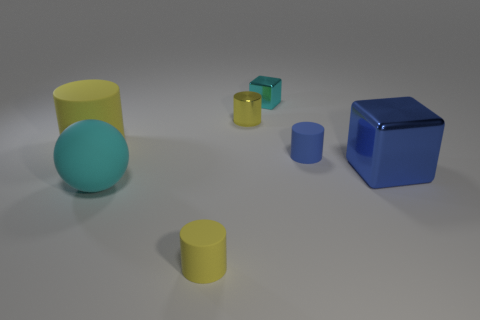The cyan object behind the yellow cylinder that is on the left side of the yellow rubber object in front of the big blue block is made of what material?
Your answer should be compact. Metal. What is the material of the small cube that is the same color as the ball?
Your answer should be compact. Metal. How many tiny blue objects are the same material as the big cylinder?
Provide a short and direct response. 1. Do the object that is on the left side of the matte sphere and the small cyan metallic cube have the same size?
Your response must be concise. No. The big cylinder that is made of the same material as the cyan ball is what color?
Your answer should be very brief. Yellow. How many blue cubes are left of the large yellow object?
Make the answer very short. 0. There is a cylinder that is in front of the big blue cube; is it the same color as the big cylinder that is left of the small cyan metal block?
Your answer should be very brief. Yes. There is a tiny metal object that is the same shape as the tiny blue rubber object; what color is it?
Keep it short and to the point. Yellow. Is there any other thing that has the same shape as the big cyan rubber thing?
Offer a very short reply. No. There is a large thing that is to the left of the big matte sphere; is its shape the same as the tiny thing in front of the large rubber sphere?
Make the answer very short. Yes. 